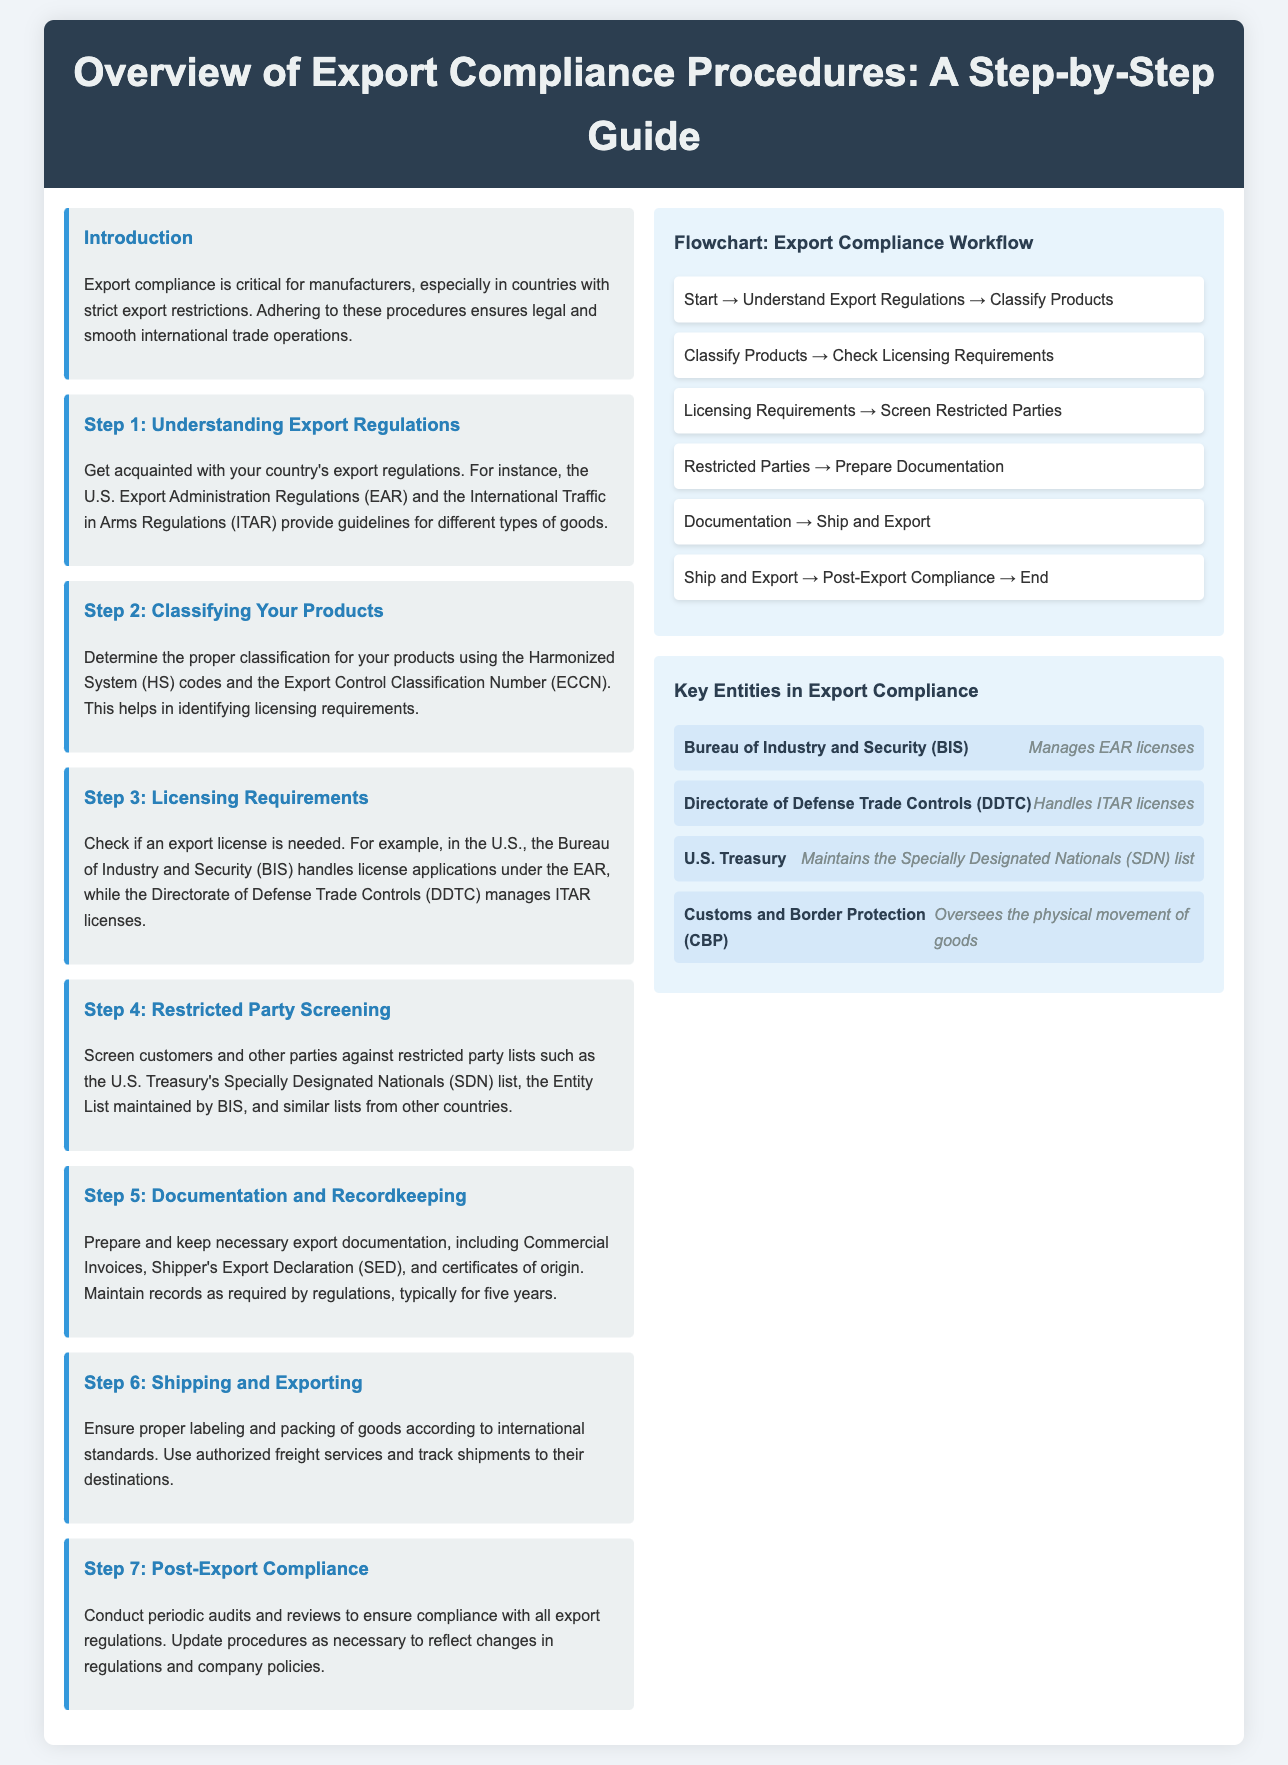What is the title of the document? The title appears at the top of the header section, describing the content of the document.
Answer: Overview of Export Compliance Procedures: A Step-by-Step Guide What is the primary focus of export compliance? The introduction explains why export compliance is important for manufacturers in terms of legal and operational matters.
Answer: Legal and smooth international trade operations Who manages EAR licenses? The infographic section lists key entities in export compliance and their roles, with BIS being the responsible organization for EAR licenses.
Answer: Bureau of Industry and Security (BIS) What step involves classifying products? The steps section outlines various steps in the compliance procedure, specifically indicating which one deals with classification.
Answer: Step 2: Classifying Your Products What document should be prepared and kept according to Step 5? Step 5 details the necessary documentation required for export compliance, specifying types of records needed.
Answer: Commercial Invoices Which entity maintains the Specially Designated Nationals list? The infographic names organizations responsible for different compliance roles, including the one that maintains this specific list.
Answer: U.S. Treasury How many steps are there in the export compliance guide? The steps section includes a total of seven steps for compliance outlined in the document.
Answer: Seven Which step comes after checking licensing requirements? The workflow flowchart visually represents the sequence of steps in the compliance procedures, indicating the next in line.
Answer: Screen Restricted Parties What is the minimum duration for recordkeeping as mentioned in Step 5? The content outlines regulatory requirements, including how long records must be kept for compliance purposes.
Answer: Five years 